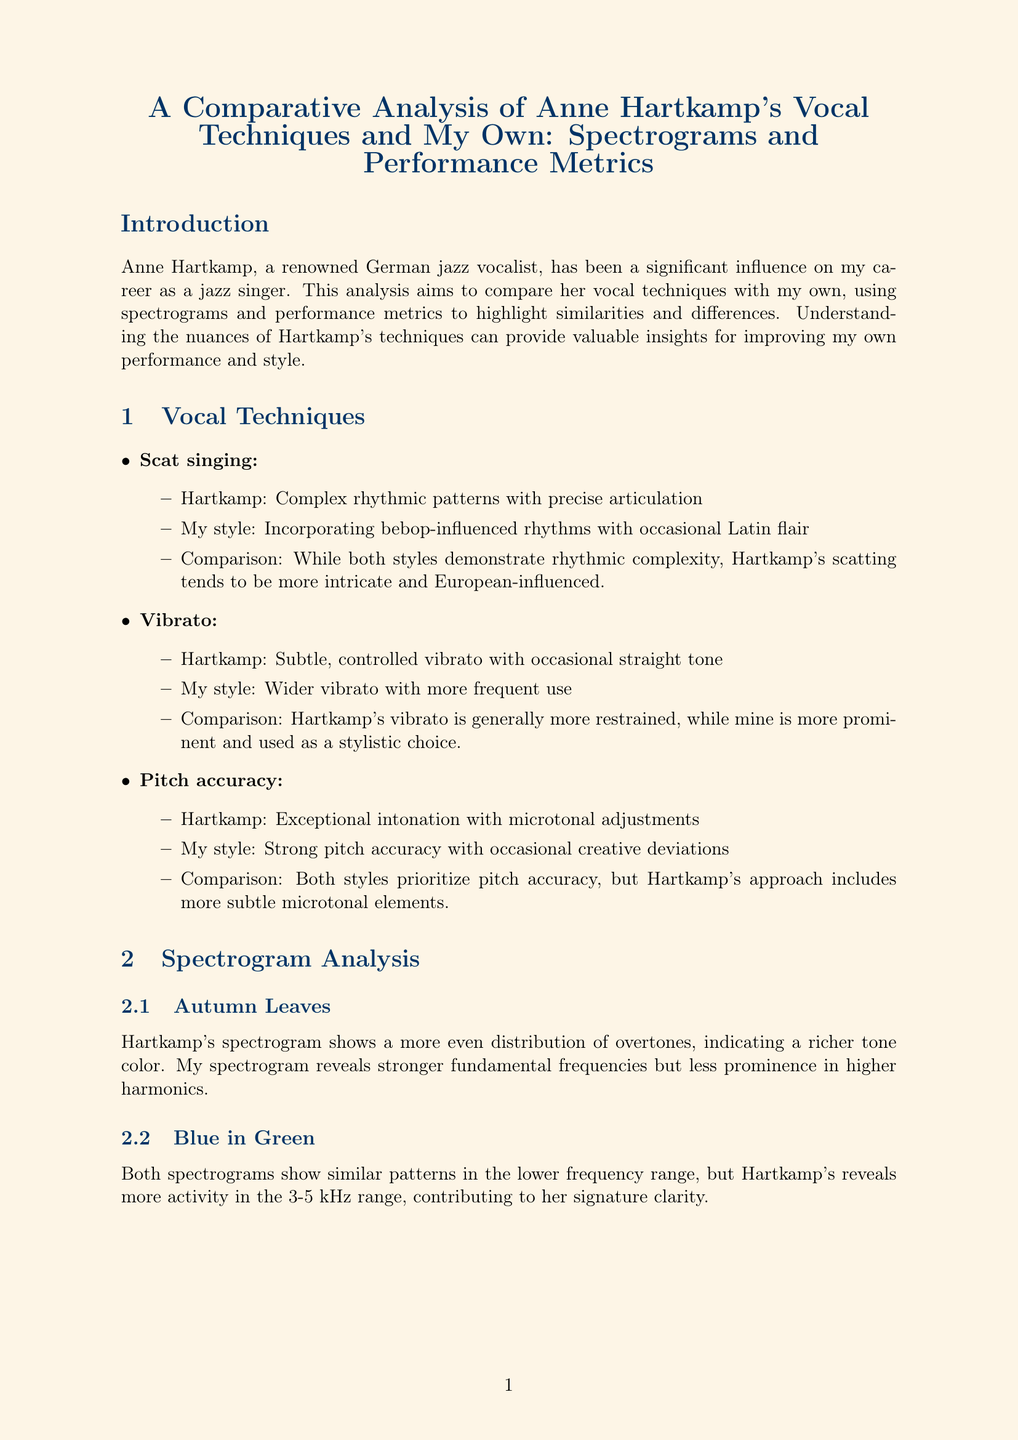What is the title of the report? The title of the report is mentioned at the beginning of the document, summarizing the study's focus.
Answer: A Comparative Analysis of Anne Hartkamp's Vocal Techniques and My Own: Spectrograms and Performance Metrics Who is the renowned German jazz vocalist referenced in the report? The document provides a name of a significant influence on the author's career as a jazz singer.
Answer: Anne Hartkamp What is Hartkamp's vibrato style? The report describes Hartkamp's vibrato style as it compares to the author's style.
Answer: Subtle, controlled vibrato with occasional straight tone What is the dynamic range value for Hartkamp? The document includes specific performance metrics and values for both vocalists.
Answer: 30 dB What song has a spectrogram that shows stronger fundamental frequencies in the author's analysis? The document includes analyses of songs, highlighting specific characteristics of the spectrograms.
Answer: Autumn Leaves What aspect of Hartkamp's technique significantly influences the author? The document discusses the author's development and influences in relation to Hartkamp's style.
Answer: Rhythm, harmonic complexity, and tonal clarity What is the author's goal for future development? The report outlines the author’s aspirations in relation to their performance improvement.
Answer: Further develop microtonal control and expand my upper register How many milliseconds is Hartkamp's vocal onset time? The performance metric table provides specific values for vocal onset time for both vocalists.
Answer: 20-30 ms Which song's spectrogram reveals more activity in the 3-5 kHz range? The document analyzes the spectrogram of each song, indicating specific observations.
Answer: Blue in Green 